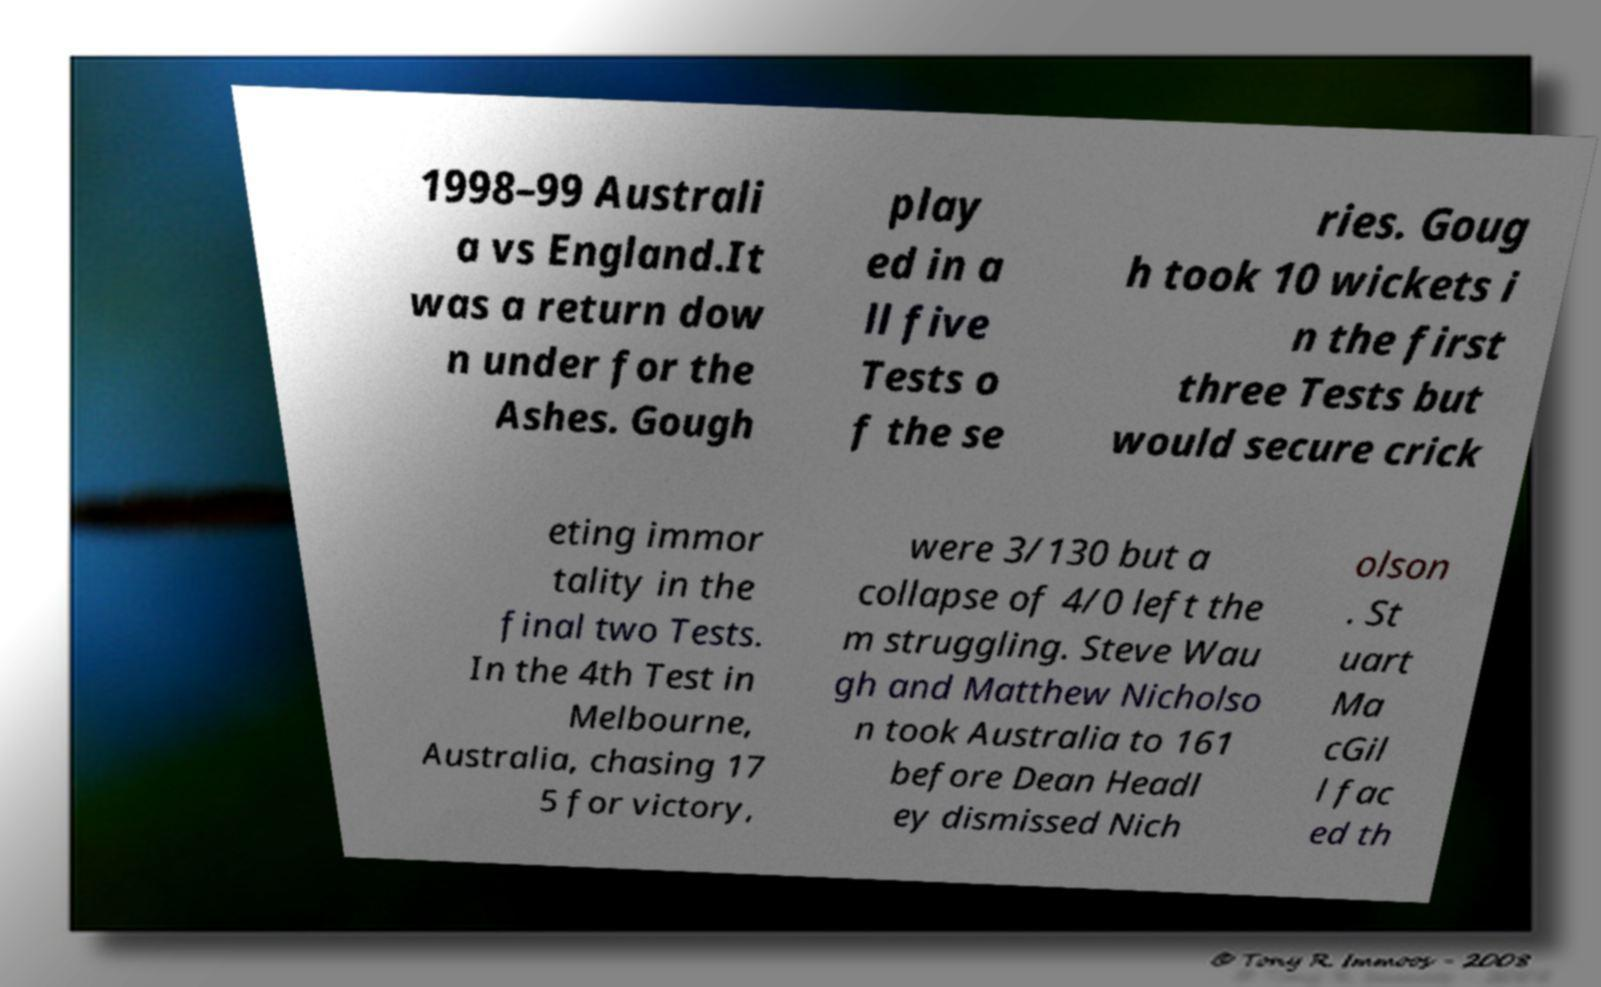Could you extract and type out the text from this image? 1998–99 Australi a vs England.It was a return dow n under for the Ashes. Gough play ed in a ll five Tests o f the se ries. Goug h took 10 wickets i n the first three Tests but would secure crick eting immor tality in the final two Tests. In the 4th Test in Melbourne, Australia, chasing 17 5 for victory, were 3/130 but a collapse of 4/0 left the m struggling. Steve Wau gh and Matthew Nicholso n took Australia to 161 before Dean Headl ey dismissed Nich olson . St uart Ma cGil l fac ed th 